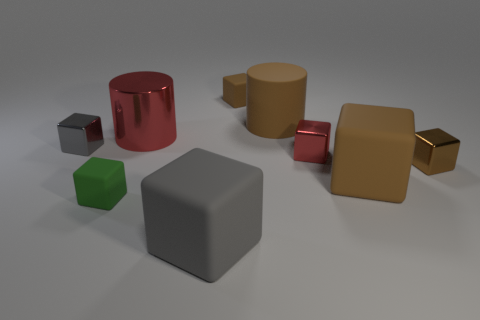Is the color of the big metal object the same as the tiny object that is behind the small gray metal object?
Give a very brief answer. No. What is the shape of the tiny thing that is to the right of the brown rubber object in front of the shiny cylinder?
Your response must be concise. Cube. Do the large brown thing that is to the right of the large brown rubber cylinder and the small green matte thing have the same shape?
Offer a terse response. Yes. Is the number of tiny brown objects that are in front of the big red metal thing greater than the number of small brown cubes in front of the brown metal thing?
Your answer should be compact. Yes. There is a cube in front of the green matte block; how many big brown cylinders are behind it?
Your response must be concise. 1. There is a block that is the same color as the large metallic cylinder; what is it made of?
Offer a very short reply. Metal. How many other things are the same color as the big metallic object?
Provide a succinct answer. 1. There is a matte thing in front of the tiny matte cube that is left of the gray rubber thing; what is its color?
Give a very brief answer. Gray. Are there any blocks that have the same color as the big rubber cylinder?
Provide a short and direct response. Yes. How many metal things are tiny gray cylinders or tiny red things?
Offer a terse response. 1. 